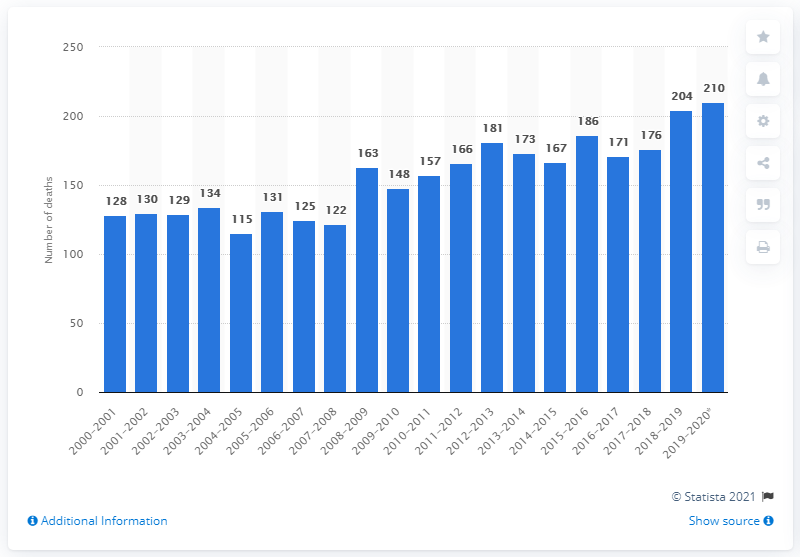Outline some significant characteristics in this image. In Nunavut, 210 people died between July 1, 2019 and June 30, 2020. 